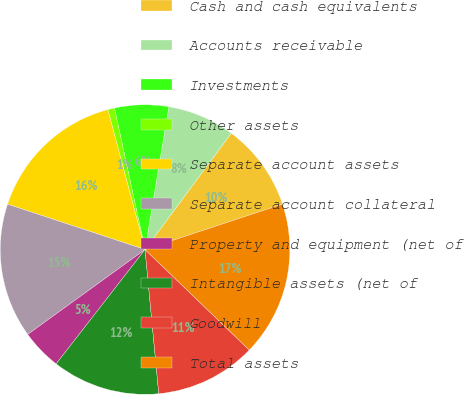<chart> <loc_0><loc_0><loc_500><loc_500><pie_chart><fcel>Cash and cash equivalents<fcel>Accounts receivable<fcel>Investments<fcel>Other assets<fcel>Separate account assets<fcel>Separate account collateral<fcel>Property and equipment (net of<fcel>Intangible assets (net of<fcel>Goodwill<fcel>Total assets<nl><fcel>9.77%<fcel>7.52%<fcel>6.02%<fcel>0.75%<fcel>15.79%<fcel>15.04%<fcel>4.51%<fcel>12.03%<fcel>11.28%<fcel>17.29%<nl></chart> 